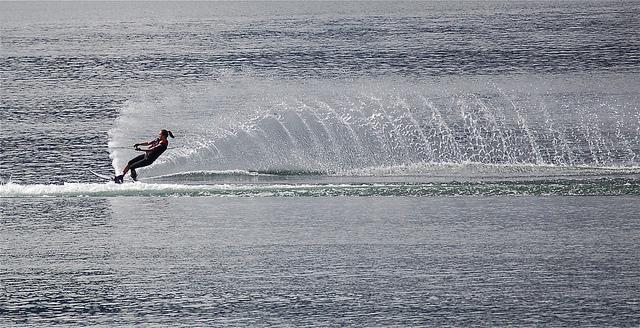Is the water still?
Answer briefly. No. Which water sport is being shown?
Be succinct. Water skiing. Is there a boat somewhere near?
Short answer required. Yes. 